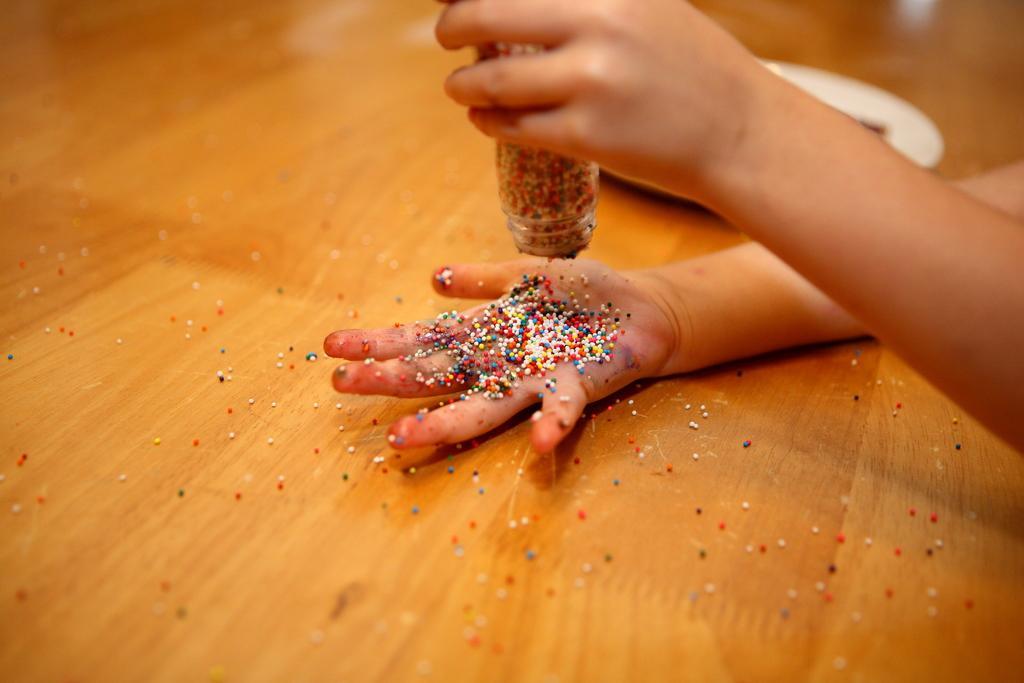Please provide a concise description of this image. As we can see in the image there is a table and a person hand holding bottle. On table there is a white color plate. 